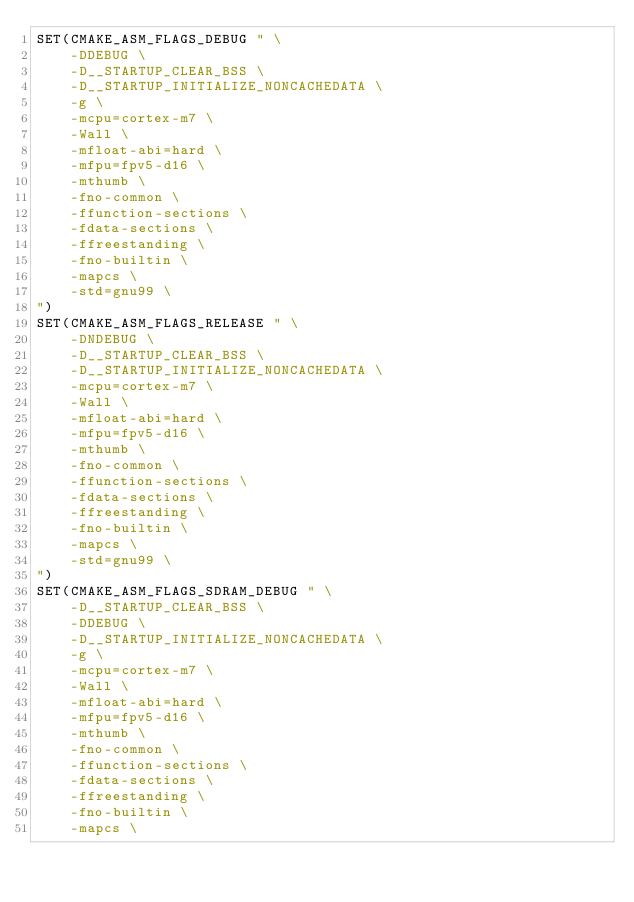<code> <loc_0><loc_0><loc_500><loc_500><_CMake_>SET(CMAKE_ASM_FLAGS_DEBUG " \
    -DDEBUG \
    -D__STARTUP_CLEAR_BSS \
    -D__STARTUP_INITIALIZE_NONCACHEDATA \
    -g \
    -mcpu=cortex-m7 \
    -Wall \
    -mfloat-abi=hard \
    -mfpu=fpv5-d16 \
    -mthumb \
    -fno-common \
    -ffunction-sections \
    -fdata-sections \
    -ffreestanding \
    -fno-builtin \
    -mapcs \
    -std=gnu99 \
")
SET(CMAKE_ASM_FLAGS_RELEASE " \
    -DNDEBUG \
    -D__STARTUP_CLEAR_BSS \
    -D__STARTUP_INITIALIZE_NONCACHEDATA \
    -mcpu=cortex-m7 \
    -Wall \
    -mfloat-abi=hard \
    -mfpu=fpv5-d16 \
    -mthumb \
    -fno-common \
    -ffunction-sections \
    -fdata-sections \
    -ffreestanding \
    -fno-builtin \
    -mapcs \
    -std=gnu99 \
")
SET(CMAKE_ASM_FLAGS_SDRAM_DEBUG " \
    -D__STARTUP_CLEAR_BSS \
    -DDEBUG \
    -D__STARTUP_INITIALIZE_NONCACHEDATA \
    -g \
    -mcpu=cortex-m7 \
    -Wall \
    -mfloat-abi=hard \
    -mfpu=fpv5-d16 \
    -mthumb \
    -fno-common \
    -ffunction-sections \
    -fdata-sections \
    -ffreestanding \
    -fno-builtin \
    -mapcs \</code> 